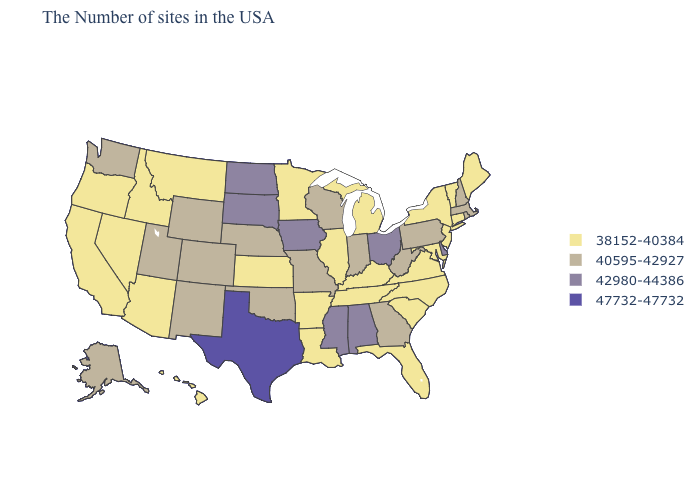What is the lowest value in the MidWest?
Concise answer only. 38152-40384. What is the lowest value in states that border Ohio?
Short answer required. 38152-40384. Which states have the highest value in the USA?
Short answer required. Texas. Does Kansas have the same value as Louisiana?
Give a very brief answer. Yes. How many symbols are there in the legend?
Answer briefly. 4. Name the states that have a value in the range 38152-40384?
Be succinct. Maine, Vermont, Connecticut, New York, New Jersey, Maryland, Virginia, North Carolina, South Carolina, Florida, Michigan, Kentucky, Tennessee, Illinois, Louisiana, Arkansas, Minnesota, Kansas, Montana, Arizona, Idaho, Nevada, California, Oregon, Hawaii. Which states have the lowest value in the USA?
Keep it brief. Maine, Vermont, Connecticut, New York, New Jersey, Maryland, Virginia, North Carolina, South Carolina, Florida, Michigan, Kentucky, Tennessee, Illinois, Louisiana, Arkansas, Minnesota, Kansas, Montana, Arizona, Idaho, Nevada, California, Oregon, Hawaii. Among the states that border Missouri , which have the highest value?
Keep it brief. Iowa. Does Pennsylvania have the lowest value in the USA?
Answer briefly. No. What is the lowest value in states that border Missouri?
Short answer required. 38152-40384. Does Texas have the highest value in the USA?
Be succinct. Yes. Name the states that have a value in the range 42980-44386?
Short answer required. Delaware, Ohio, Alabama, Mississippi, Iowa, South Dakota, North Dakota. Name the states that have a value in the range 40595-42927?
Write a very short answer. Massachusetts, Rhode Island, New Hampshire, Pennsylvania, West Virginia, Georgia, Indiana, Wisconsin, Missouri, Nebraska, Oklahoma, Wyoming, Colorado, New Mexico, Utah, Washington, Alaska. What is the value of Kansas?
Give a very brief answer. 38152-40384. Does Virginia have the lowest value in the USA?
Be succinct. Yes. 